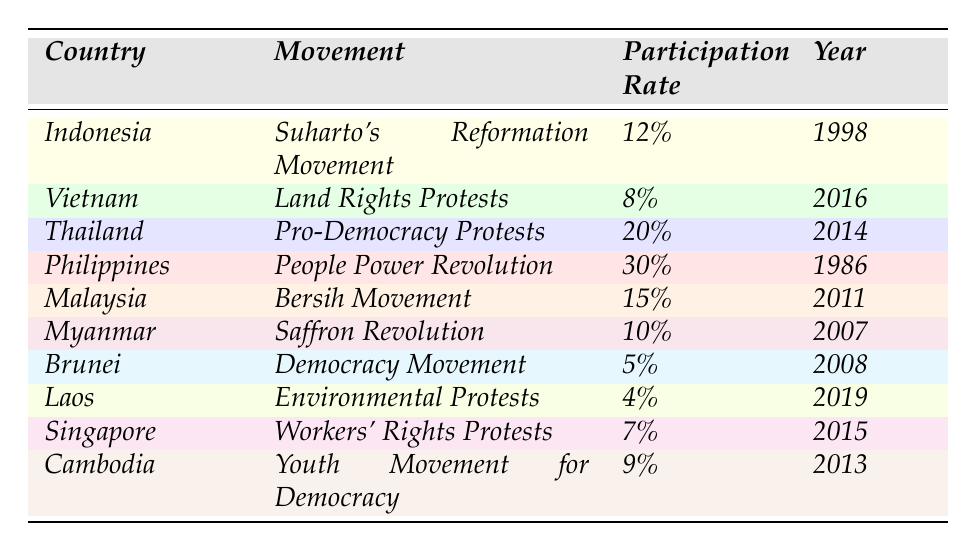What was the highest participation rate in social movements across these countries? The table shows various participation rates, with the highest being 30% for the People Power Revolution in the Philippines in 1986.
Answer: 30% Which country had the lowest participation rate in social movements? Looking at the table, Laos had the lowest participation rate at 4% during the environmental protests in 2019.
Answer: 4% What was the participation rate of the Suharto's Reformation Movement? The table specifically states that the participation rate for Suharto's Reformation Movement in Indonesia in 1998 was 12%.
Answer: 12% Is the participation rate in Myanmar’s Saffron Revolution greater than 10%? The table indicates that the participation rate in Myanmar's Saffron Revolution was 10%, which is not greater than 10%. Therefore, the answer is no.
Answer: No How many movements had a participation rate above 10%? The movements in the Philippines, Thailand, Indonesia, and Malaysia had rates above 10%, totaling four movements.
Answer: 4 If you average the participation rates of the Bersih Movement and the Pro-Democracy Protests, what would that be? The Bersih Movement had a participation rate of 15% and the Pro-Democracy Protests had a rate of 20%. The average is (15 + 20) / 2 = 17.5%.
Answer: 17.5% Which two countries had movements with a participation rate below 10%? The table indicates Brunei with 5% and Laos with 4% both had movements with participation rates below 10%.
Answer: Brunei and Laos Did Vietnam’s Land Rights Protests have a higher or lower participation rate than Malaysia’s Bersih Movement? Vietnam's Land Rights Protests had a participation rate of 8%, while Malaysia’s Bersih Movement had 15%. Therefore, Vietnam's rate is lower.
Answer: Lower What percentage difference is there between the participation rates of the People Power Revolution and the Saffron Revolution? The People Power Revolution had a participation rate of 30%, and the Saffron Revolution had a rate of 10%. The difference is 30 - 10 = 20%.
Answer: 20% What is the combined participation rate of all the movements listed in 2016 and onwards? The relevant movements after 2016 are the Land Rights Protests (8%), the Bersih Movement (15%), and the Environmental Protests (4%). Adding these rates gives 8 + 15 + 4 = 27%.
Answer: 27% 